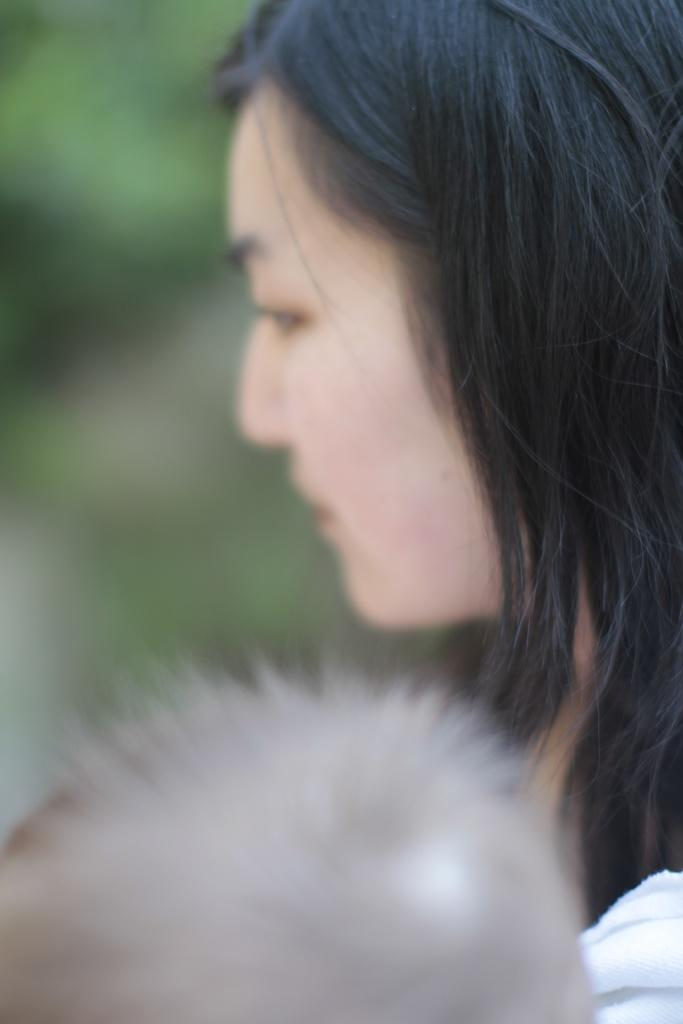What is the main subject of the image? There is a girl's face in the middle of the image. What can be seen at the bottom of the image? There is hair at the bottom of the image. How would you describe the background of the image? The background of the image is blurry. What type of science experiment is being conducted in the image? There is no indication of a science experiment in the image; it primarily features a girl's face and hair. Can you see any jellyfish in the image? There is no mention of jellyfish in the image, and they are not visible in the provided facts. 